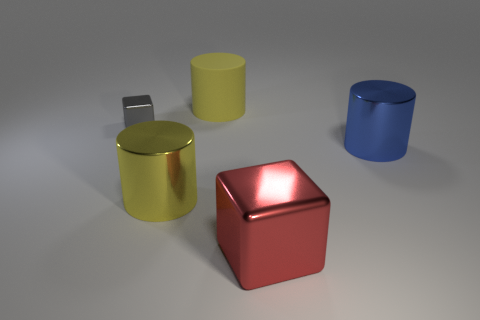Subtract all gray balls. How many yellow cylinders are left? 2 Subtract all metal cylinders. How many cylinders are left? 1 Subtract 1 cylinders. How many cylinders are left? 2 Add 2 blue metallic cylinders. How many objects exist? 7 Subtract all cubes. How many objects are left? 3 Subtract 0 blue cubes. How many objects are left? 5 Subtract all large gray shiny cylinders. Subtract all large shiny blocks. How many objects are left? 4 Add 3 big blue metallic things. How many big blue metallic things are left? 4 Add 5 big yellow metallic cylinders. How many big yellow metallic cylinders exist? 6 